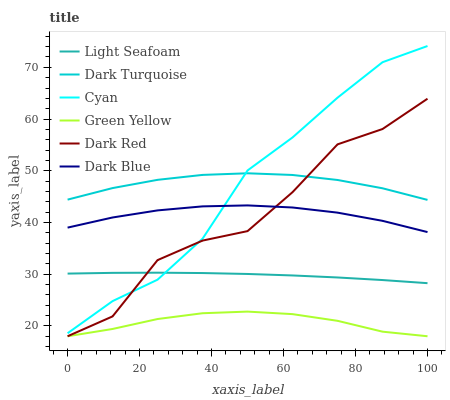Does Green Yellow have the minimum area under the curve?
Answer yes or no. Yes. Does Dark Turquoise have the maximum area under the curve?
Answer yes or no. Yes. Does Dark Blue have the minimum area under the curve?
Answer yes or no. No. Does Dark Blue have the maximum area under the curve?
Answer yes or no. No. Is Light Seafoam the smoothest?
Answer yes or no. Yes. Is Dark Red the roughest?
Answer yes or no. Yes. Is Dark Turquoise the smoothest?
Answer yes or no. No. Is Dark Turquoise the roughest?
Answer yes or no. No. Does Dark Red have the lowest value?
Answer yes or no. Yes. Does Dark Blue have the lowest value?
Answer yes or no. No. Does Cyan have the highest value?
Answer yes or no. Yes. Does Dark Turquoise have the highest value?
Answer yes or no. No. Is Light Seafoam less than Dark Turquoise?
Answer yes or no. Yes. Is Dark Blue greater than Green Yellow?
Answer yes or no. Yes. Does Dark Red intersect Dark Blue?
Answer yes or no. Yes. Is Dark Red less than Dark Blue?
Answer yes or no. No. Is Dark Red greater than Dark Blue?
Answer yes or no. No. Does Light Seafoam intersect Dark Turquoise?
Answer yes or no. No. 